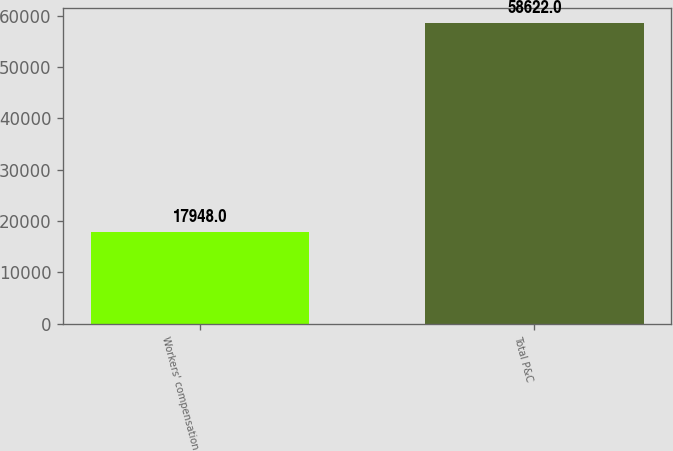Convert chart to OTSL. <chart><loc_0><loc_0><loc_500><loc_500><bar_chart><fcel>Workers' compensation<fcel>Total P&C<nl><fcel>17948<fcel>58622<nl></chart> 